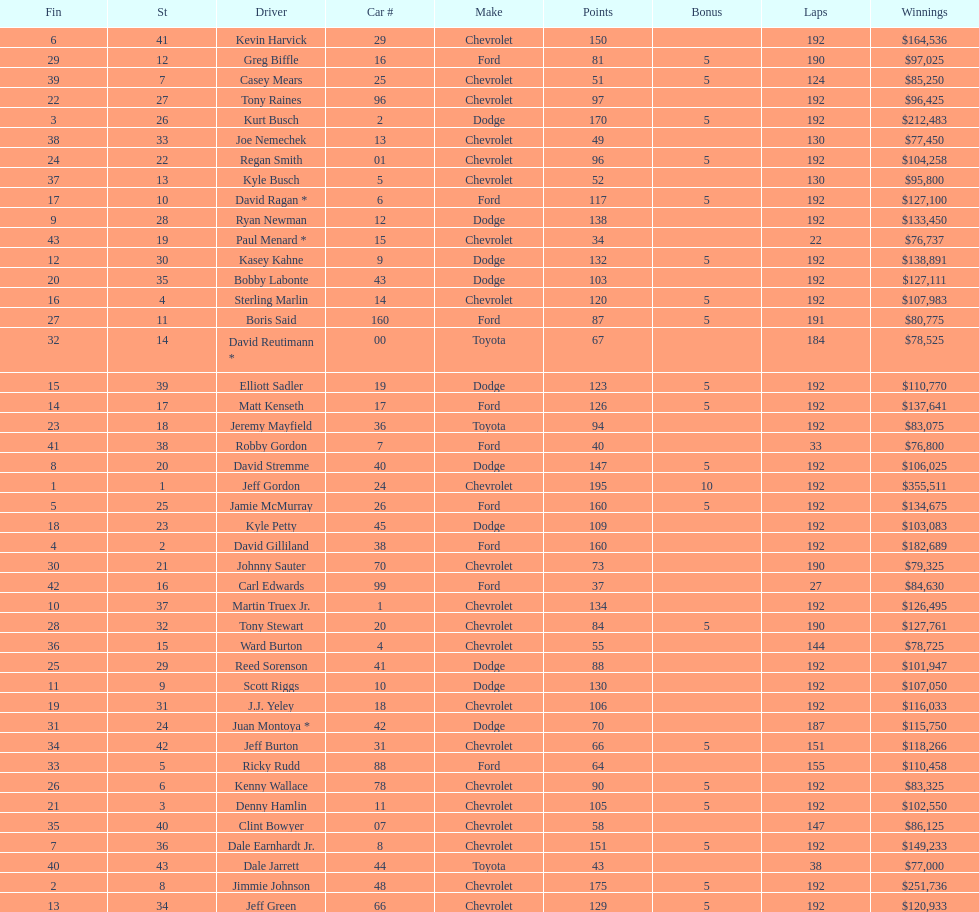Parse the full table. {'header': ['Fin', 'St', 'Driver', 'Car #', 'Make', 'Points', 'Bonus', 'Laps', 'Winnings'], 'rows': [['6', '41', 'Kevin Harvick', '29', 'Chevrolet', '150', '', '192', '$164,536'], ['29', '12', 'Greg Biffle', '16', 'Ford', '81', '5', '190', '$97,025'], ['39', '7', 'Casey Mears', '25', 'Chevrolet', '51', '5', '124', '$85,250'], ['22', '27', 'Tony Raines', '96', 'Chevrolet', '97', '', '192', '$96,425'], ['3', '26', 'Kurt Busch', '2', 'Dodge', '170', '5', '192', '$212,483'], ['38', '33', 'Joe Nemechek', '13', 'Chevrolet', '49', '', '130', '$77,450'], ['24', '22', 'Regan Smith', '01', 'Chevrolet', '96', '5', '192', '$104,258'], ['37', '13', 'Kyle Busch', '5', 'Chevrolet', '52', '', '130', '$95,800'], ['17', '10', 'David Ragan *', '6', 'Ford', '117', '5', '192', '$127,100'], ['9', '28', 'Ryan Newman', '12', 'Dodge', '138', '', '192', '$133,450'], ['43', '19', 'Paul Menard *', '15', 'Chevrolet', '34', '', '22', '$76,737'], ['12', '30', 'Kasey Kahne', '9', 'Dodge', '132', '5', '192', '$138,891'], ['20', '35', 'Bobby Labonte', '43', 'Dodge', '103', '', '192', '$127,111'], ['16', '4', 'Sterling Marlin', '14', 'Chevrolet', '120', '5', '192', '$107,983'], ['27', '11', 'Boris Said', '160', 'Ford', '87', '5', '191', '$80,775'], ['32', '14', 'David Reutimann *', '00', 'Toyota', '67', '', '184', '$78,525'], ['15', '39', 'Elliott Sadler', '19', 'Dodge', '123', '5', '192', '$110,770'], ['14', '17', 'Matt Kenseth', '17', 'Ford', '126', '5', '192', '$137,641'], ['23', '18', 'Jeremy Mayfield', '36', 'Toyota', '94', '', '192', '$83,075'], ['41', '38', 'Robby Gordon', '7', 'Ford', '40', '', '33', '$76,800'], ['8', '20', 'David Stremme', '40', 'Dodge', '147', '5', '192', '$106,025'], ['1', '1', 'Jeff Gordon', '24', 'Chevrolet', '195', '10', '192', '$355,511'], ['5', '25', 'Jamie McMurray', '26', 'Ford', '160', '5', '192', '$134,675'], ['18', '23', 'Kyle Petty', '45', 'Dodge', '109', '', '192', '$103,083'], ['4', '2', 'David Gilliland', '38', 'Ford', '160', '', '192', '$182,689'], ['30', '21', 'Johnny Sauter', '70', 'Chevrolet', '73', '', '190', '$79,325'], ['42', '16', 'Carl Edwards', '99', 'Ford', '37', '', '27', '$84,630'], ['10', '37', 'Martin Truex Jr.', '1', 'Chevrolet', '134', '', '192', '$126,495'], ['28', '32', 'Tony Stewart', '20', 'Chevrolet', '84', '5', '190', '$127,761'], ['36', '15', 'Ward Burton', '4', 'Chevrolet', '55', '', '144', '$78,725'], ['25', '29', 'Reed Sorenson', '41', 'Dodge', '88', '', '192', '$101,947'], ['11', '9', 'Scott Riggs', '10', 'Dodge', '130', '', '192', '$107,050'], ['19', '31', 'J.J. Yeley', '18', 'Chevrolet', '106', '', '192', '$116,033'], ['31', '24', 'Juan Montoya *', '42', 'Dodge', '70', '', '187', '$115,750'], ['34', '42', 'Jeff Burton', '31', 'Chevrolet', '66', '5', '151', '$118,266'], ['33', '5', 'Ricky Rudd', '88', 'Ford', '64', '', '155', '$110,458'], ['26', '6', 'Kenny Wallace', '78', 'Chevrolet', '90', '5', '192', '$83,325'], ['21', '3', 'Denny Hamlin', '11', 'Chevrolet', '105', '5', '192', '$102,550'], ['35', '40', 'Clint Bowyer', '07', 'Chevrolet', '58', '', '147', '$86,125'], ['7', '36', 'Dale Earnhardt Jr.', '8', 'Chevrolet', '151', '5', '192', '$149,233'], ['40', '43', 'Dale Jarrett', '44', 'Toyota', '43', '', '38', '$77,000'], ['2', '8', 'Jimmie Johnson', '48', 'Chevrolet', '175', '5', '192', '$251,736'], ['13', '34', 'Jeff Green', '66', 'Chevrolet', '129', '5', '192', '$120,933']]} What was the brand of both jeff gordon's and jimmie johnson's racing vehicle? Chevrolet. 